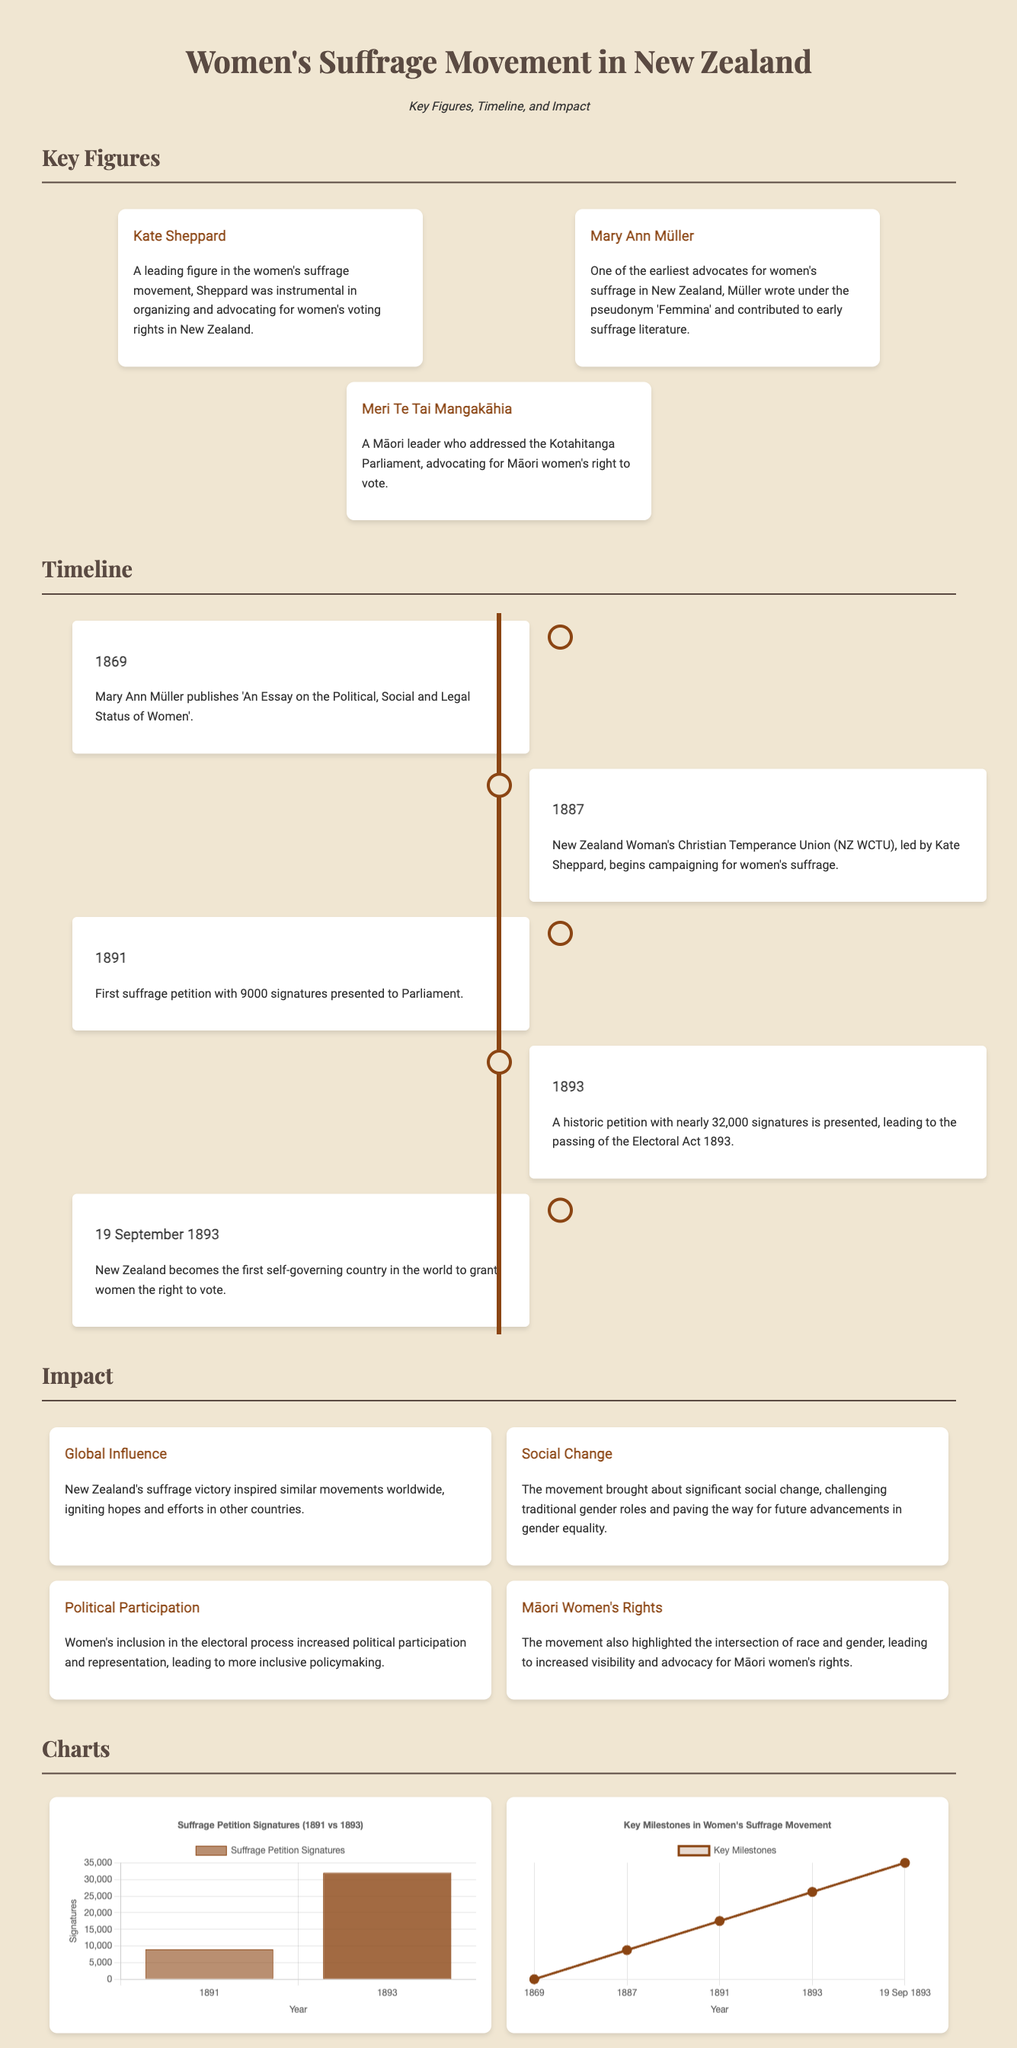What year did New Zealand grant women the right to vote? The document states that New Zealand became the first self-governing country to grant women the right to vote on 19 September 1893.
Answer: 1893 Who was a leading figure in the women's suffrage movement? The document highlights Kate Sheppard as a leading figure in the women's suffrage movement.
Answer: Kate Sheppard What was the total number of signatures in the historic petition presented in 1893? The document indicates that the historic petition presented in 1893 had nearly 32,000 signatures.
Answer: 32,000 Which organization began campaigning for women's suffrage in 1887? The New Zealand Woman's Christian Temperance Union (NZ WCTU) is mentioned as the organization that began campaigning for women's suffrage in 1887.
Answer: NZ WCTU What is depicted in the line chart related to the Women's Suffrage Movement? The line chart is labeled "Key Milestones in Women's Suffrage Movement" and shows important events by year.
Answer: Key Milestones How many signatures were on the first suffrage petition presented to Parliament in 1891? The document states that the first suffrage petition presented to Parliament in 1891 had 9000 signatures.
Answer: 9000 Which impact highlights the increased political representation due to women's suffrage? The document lists "Political Participation" as one of the impacts highlighting increased representation after women's suffrage.
Answer: Political Participation Which notable figure wrote under the pseudonym 'Femmina'? The document mentions Mary Ann Müller as someone who wrote under the pseudonym 'Femmina'.
Answer: Mary Ann Müller 